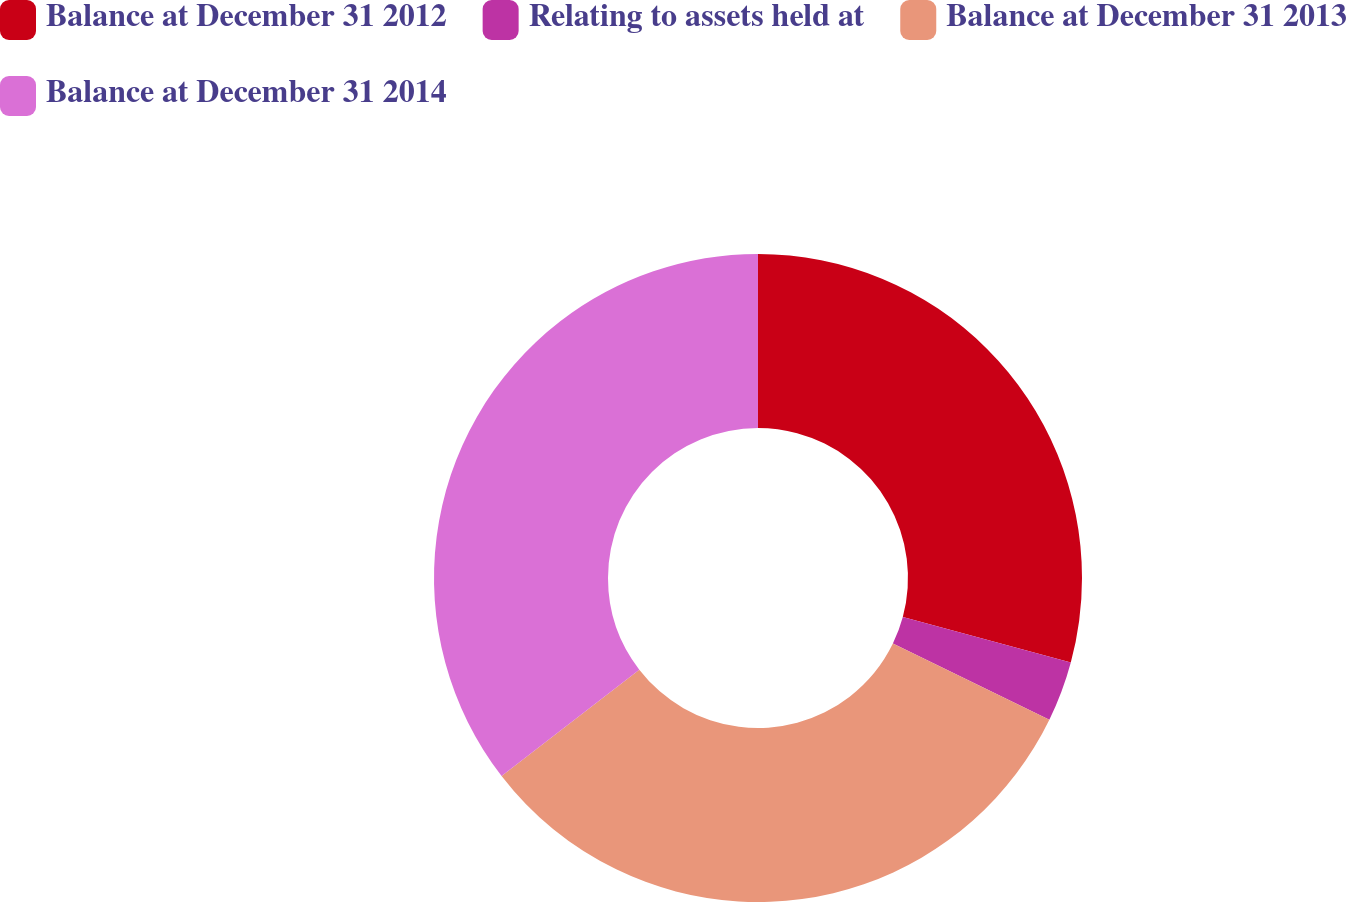Convert chart to OTSL. <chart><loc_0><loc_0><loc_500><loc_500><pie_chart><fcel>Balance at December 31 2012<fcel>Relating to assets held at<fcel>Balance at December 31 2013<fcel>Balance at December 31 2014<nl><fcel>29.2%<fcel>3.01%<fcel>32.33%<fcel>35.47%<nl></chart> 